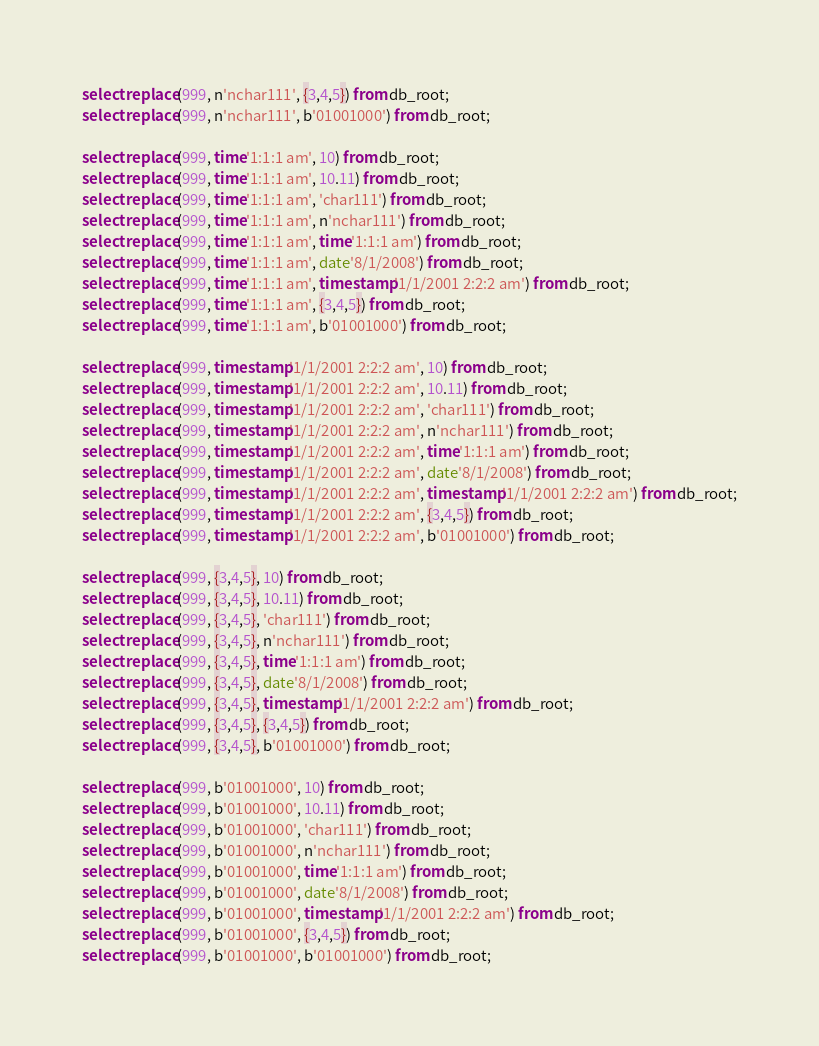<code> <loc_0><loc_0><loc_500><loc_500><_SQL_>select replace(999, n'nchar111', {3,4,5}) from db_root;
select replace(999, n'nchar111', b'01001000') from db_root;

select replace(999, time'1:1:1 am', 10) from db_root;
select replace(999, time'1:1:1 am', 10.11) from db_root;
select replace(999, time'1:1:1 am', 'char111') from db_root;
select replace(999, time'1:1:1 am', n'nchar111') from db_root;
select replace(999, time'1:1:1 am', time'1:1:1 am') from db_root;
select replace(999, time'1:1:1 am', date'8/1/2008') from db_root;
select replace(999, time'1:1:1 am', timestamp'1/1/2001 2:2:2 am') from db_root;
select replace(999, time'1:1:1 am', {3,4,5}) from db_root;
select replace(999, time'1:1:1 am', b'01001000') from db_root;

select replace(999, timestamp'1/1/2001 2:2:2 am', 10) from db_root;
select replace(999, timestamp'1/1/2001 2:2:2 am', 10.11) from db_root;
select replace(999, timestamp'1/1/2001 2:2:2 am', 'char111') from db_root;
select replace(999, timestamp'1/1/2001 2:2:2 am', n'nchar111') from db_root;
select replace(999, timestamp'1/1/2001 2:2:2 am', time'1:1:1 am') from db_root;
select replace(999, timestamp'1/1/2001 2:2:2 am', date'8/1/2008') from db_root;
select replace(999, timestamp'1/1/2001 2:2:2 am', timestamp'1/1/2001 2:2:2 am') from db_root;
select replace(999, timestamp'1/1/2001 2:2:2 am', {3,4,5}) from db_root;
select replace(999, timestamp'1/1/2001 2:2:2 am', b'01001000') from db_root;

select replace(999, {3,4,5}, 10) from db_root;
select replace(999, {3,4,5}, 10.11) from db_root;
select replace(999, {3,4,5}, 'char111') from db_root;
select replace(999, {3,4,5}, n'nchar111') from db_root;
select replace(999, {3,4,5}, time'1:1:1 am') from db_root;
select replace(999, {3,4,5}, date'8/1/2008') from db_root;
select replace(999, {3,4,5}, timestamp'1/1/2001 2:2:2 am') from db_root;
select replace(999, {3,4,5}, {3,4,5}) from db_root;
select replace(999, {3,4,5}, b'01001000') from db_root;

select replace(999, b'01001000', 10) from db_root;
select replace(999, b'01001000', 10.11) from db_root;
select replace(999, b'01001000', 'char111') from db_root;
select replace(999, b'01001000', n'nchar111') from db_root;
select replace(999, b'01001000', time'1:1:1 am') from db_root;
select replace(999, b'01001000', date'8/1/2008') from db_root;
select replace(999, b'01001000', timestamp'1/1/2001 2:2:2 am') from db_root;
select replace(999, b'01001000', {3,4,5}) from db_root;
select replace(999, b'01001000', b'01001000') from db_root;
</code> 